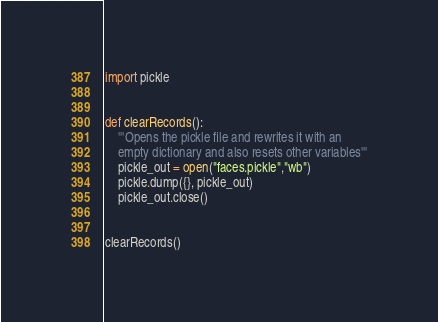<code> <loc_0><loc_0><loc_500><loc_500><_Python_>import pickle


def clearRecords():
    '''Opens the pickle file and rewrites it with an
    empty dictionary and also resets other variables'''
    pickle_out = open("faces.pickle","wb")
    pickle.dump({}, pickle_out)
    pickle_out.close()


clearRecords()
</code> 